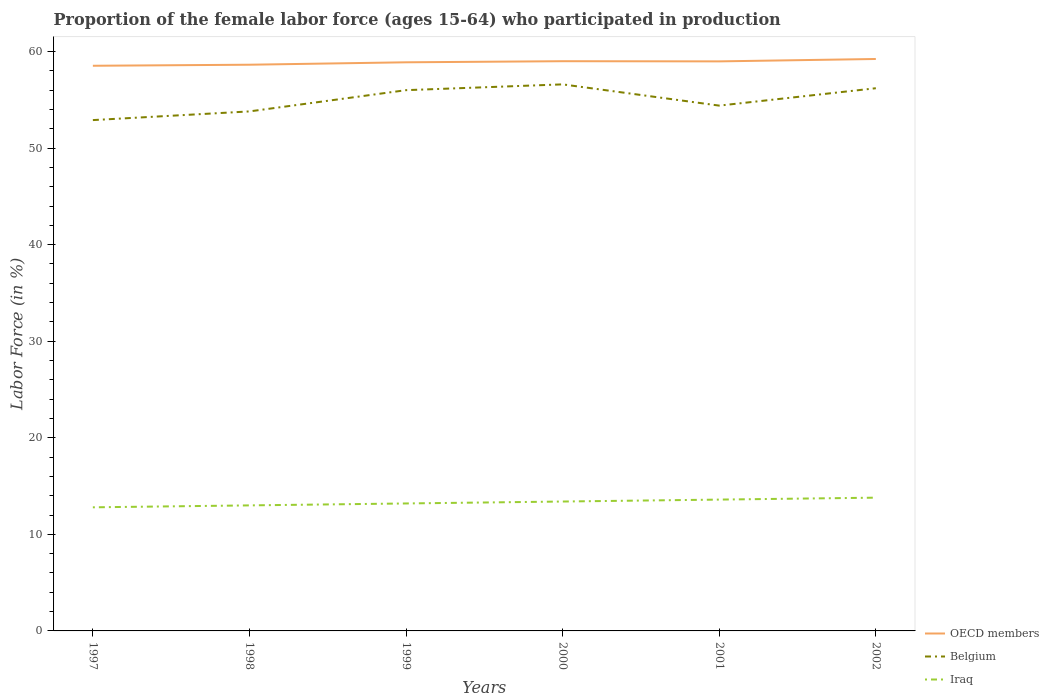Is the number of lines equal to the number of legend labels?
Ensure brevity in your answer.  Yes. Across all years, what is the maximum proportion of the female labor force who participated in production in OECD members?
Provide a succinct answer. 58.53. What is the total proportion of the female labor force who participated in production in Iraq in the graph?
Keep it short and to the point. -0.8. What is the difference between the highest and the second highest proportion of the female labor force who participated in production in OECD members?
Keep it short and to the point. 0.7. How many years are there in the graph?
Offer a very short reply. 6. How many legend labels are there?
Make the answer very short. 3. What is the title of the graph?
Make the answer very short. Proportion of the female labor force (ages 15-64) who participated in production. Does "Gambia, The" appear as one of the legend labels in the graph?
Offer a very short reply. No. What is the label or title of the X-axis?
Provide a succinct answer. Years. What is the Labor Force (in %) of OECD members in 1997?
Provide a succinct answer. 58.53. What is the Labor Force (in %) in Belgium in 1997?
Offer a very short reply. 52.9. What is the Labor Force (in %) in Iraq in 1997?
Provide a succinct answer. 12.8. What is the Labor Force (in %) in OECD members in 1998?
Provide a short and direct response. 58.64. What is the Labor Force (in %) of Belgium in 1998?
Ensure brevity in your answer.  53.8. What is the Labor Force (in %) of OECD members in 1999?
Your answer should be very brief. 58.89. What is the Labor Force (in %) in Iraq in 1999?
Give a very brief answer. 13.2. What is the Labor Force (in %) in OECD members in 2000?
Give a very brief answer. 59. What is the Labor Force (in %) of Belgium in 2000?
Your answer should be compact. 56.6. What is the Labor Force (in %) in Iraq in 2000?
Your answer should be very brief. 13.4. What is the Labor Force (in %) of OECD members in 2001?
Provide a succinct answer. 58.98. What is the Labor Force (in %) in Belgium in 2001?
Your answer should be very brief. 54.4. What is the Labor Force (in %) of Iraq in 2001?
Offer a terse response. 13.6. What is the Labor Force (in %) in OECD members in 2002?
Offer a terse response. 59.23. What is the Labor Force (in %) of Belgium in 2002?
Give a very brief answer. 56.2. What is the Labor Force (in %) in Iraq in 2002?
Keep it short and to the point. 13.8. Across all years, what is the maximum Labor Force (in %) of OECD members?
Provide a short and direct response. 59.23. Across all years, what is the maximum Labor Force (in %) in Belgium?
Your answer should be compact. 56.6. Across all years, what is the maximum Labor Force (in %) of Iraq?
Provide a succinct answer. 13.8. Across all years, what is the minimum Labor Force (in %) of OECD members?
Provide a succinct answer. 58.53. Across all years, what is the minimum Labor Force (in %) of Belgium?
Ensure brevity in your answer.  52.9. Across all years, what is the minimum Labor Force (in %) in Iraq?
Provide a succinct answer. 12.8. What is the total Labor Force (in %) in OECD members in the graph?
Ensure brevity in your answer.  353.26. What is the total Labor Force (in %) in Belgium in the graph?
Your answer should be very brief. 329.9. What is the total Labor Force (in %) of Iraq in the graph?
Make the answer very short. 79.8. What is the difference between the Labor Force (in %) in OECD members in 1997 and that in 1998?
Ensure brevity in your answer.  -0.11. What is the difference between the Labor Force (in %) of Belgium in 1997 and that in 1998?
Make the answer very short. -0.9. What is the difference between the Labor Force (in %) of Iraq in 1997 and that in 1998?
Your answer should be compact. -0.2. What is the difference between the Labor Force (in %) in OECD members in 1997 and that in 1999?
Your answer should be compact. -0.36. What is the difference between the Labor Force (in %) in OECD members in 1997 and that in 2000?
Provide a short and direct response. -0.47. What is the difference between the Labor Force (in %) in Belgium in 1997 and that in 2000?
Offer a very short reply. -3.7. What is the difference between the Labor Force (in %) of Iraq in 1997 and that in 2000?
Provide a short and direct response. -0.6. What is the difference between the Labor Force (in %) in OECD members in 1997 and that in 2001?
Offer a terse response. -0.46. What is the difference between the Labor Force (in %) in Belgium in 1997 and that in 2001?
Keep it short and to the point. -1.5. What is the difference between the Labor Force (in %) in OECD members in 1997 and that in 2002?
Give a very brief answer. -0.7. What is the difference between the Labor Force (in %) in Belgium in 1997 and that in 2002?
Your answer should be very brief. -3.3. What is the difference between the Labor Force (in %) of OECD members in 1998 and that in 1999?
Keep it short and to the point. -0.25. What is the difference between the Labor Force (in %) in Belgium in 1998 and that in 1999?
Provide a short and direct response. -2.2. What is the difference between the Labor Force (in %) of OECD members in 1998 and that in 2000?
Give a very brief answer. -0.36. What is the difference between the Labor Force (in %) of Belgium in 1998 and that in 2000?
Your response must be concise. -2.8. What is the difference between the Labor Force (in %) of Iraq in 1998 and that in 2000?
Your answer should be compact. -0.4. What is the difference between the Labor Force (in %) in OECD members in 1998 and that in 2001?
Give a very brief answer. -0.35. What is the difference between the Labor Force (in %) of Belgium in 1998 and that in 2001?
Your answer should be very brief. -0.6. What is the difference between the Labor Force (in %) of Iraq in 1998 and that in 2001?
Keep it short and to the point. -0.6. What is the difference between the Labor Force (in %) in OECD members in 1998 and that in 2002?
Provide a succinct answer. -0.59. What is the difference between the Labor Force (in %) of Belgium in 1998 and that in 2002?
Ensure brevity in your answer.  -2.4. What is the difference between the Labor Force (in %) in OECD members in 1999 and that in 2000?
Keep it short and to the point. -0.11. What is the difference between the Labor Force (in %) of Belgium in 1999 and that in 2000?
Give a very brief answer. -0.6. What is the difference between the Labor Force (in %) in OECD members in 1999 and that in 2001?
Keep it short and to the point. -0.1. What is the difference between the Labor Force (in %) in OECD members in 1999 and that in 2002?
Offer a terse response. -0.34. What is the difference between the Labor Force (in %) of Iraq in 1999 and that in 2002?
Offer a terse response. -0.6. What is the difference between the Labor Force (in %) in OECD members in 2000 and that in 2001?
Your answer should be compact. 0.02. What is the difference between the Labor Force (in %) in OECD members in 2000 and that in 2002?
Your response must be concise. -0.23. What is the difference between the Labor Force (in %) in OECD members in 2001 and that in 2002?
Keep it short and to the point. -0.25. What is the difference between the Labor Force (in %) in Iraq in 2001 and that in 2002?
Keep it short and to the point. -0.2. What is the difference between the Labor Force (in %) of OECD members in 1997 and the Labor Force (in %) of Belgium in 1998?
Provide a succinct answer. 4.73. What is the difference between the Labor Force (in %) in OECD members in 1997 and the Labor Force (in %) in Iraq in 1998?
Ensure brevity in your answer.  45.53. What is the difference between the Labor Force (in %) of Belgium in 1997 and the Labor Force (in %) of Iraq in 1998?
Offer a very short reply. 39.9. What is the difference between the Labor Force (in %) in OECD members in 1997 and the Labor Force (in %) in Belgium in 1999?
Your response must be concise. 2.53. What is the difference between the Labor Force (in %) of OECD members in 1997 and the Labor Force (in %) of Iraq in 1999?
Provide a short and direct response. 45.33. What is the difference between the Labor Force (in %) of Belgium in 1997 and the Labor Force (in %) of Iraq in 1999?
Offer a very short reply. 39.7. What is the difference between the Labor Force (in %) of OECD members in 1997 and the Labor Force (in %) of Belgium in 2000?
Give a very brief answer. 1.93. What is the difference between the Labor Force (in %) of OECD members in 1997 and the Labor Force (in %) of Iraq in 2000?
Keep it short and to the point. 45.13. What is the difference between the Labor Force (in %) of Belgium in 1997 and the Labor Force (in %) of Iraq in 2000?
Offer a terse response. 39.5. What is the difference between the Labor Force (in %) in OECD members in 1997 and the Labor Force (in %) in Belgium in 2001?
Your response must be concise. 4.13. What is the difference between the Labor Force (in %) of OECD members in 1997 and the Labor Force (in %) of Iraq in 2001?
Your answer should be compact. 44.93. What is the difference between the Labor Force (in %) of Belgium in 1997 and the Labor Force (in %) of Iraq in 2001?
Your answer should be very brief. 39.3. What is the difference between the Labor Force (in %) of OECD members in 1997 and the Labor Force (in %) of Belgium in 2002?
Your response must be concise. 2.33. What is the difference between the Labor Force (in %) of OECD members in 1997 and the Labor Force (in %) of Iraq in 2002?
Your answer should be very brief. 44.73. What is the difference between the Labor Force (in %) in Belgium in 1997 and the Labor Force (in %) in Iraq in 2002?
Offer a terse response. 39.1. What is the difference between the Labor Force (in %) in OECD members in 1998 and the Labor Force (in %) in Belgium in 1999?
Your response must be concise. 2.64. What is the difference between the Labor Force (in %) in OECD members in 1998 and the Labor Force (in %) in Iraq in 1999?
Make the answer very short. 45.44. What is the difference between the Labor Force (in %) of Belgium in 1998 and the Labor Force (in %) of Iraq in 1999?
Give a very brief answer. 40.6. What is the difference between the Labor Force (in %) in OECD members in 1998 and the Labor Force (in %) in Belgium in 2000?
Your response must be concise. 2.04. What is the difference between the Labor Force (in %) in OECD members in 1998 and the Labor Force (in %) in Iraq in 2000?
Provide a short and direct response. 45.24. What is the difference between the Labor Force (in %) of Belgium in 1998 and the Labor Force (in %) of Iraq in 2000?
Offer a terse response. 40.4. What is the difference between the Labor Force (in %) of OECD members in 1998 and the Labor Force (in %) of Belgium in 2001?
Offer a terse response. 4.24. What is the difference between the Labor Force (in %) of OECD members in 1998 and the Labor Force (in %) of Iraq in 2001?
Offer a terse response. 45.04. What is the difference between the Labor Force (in %) of Belgium in 1998 and the Labor Force (in %) of Iraq in 2001?
Your answer should be very brief. 40.2. What is the difference between the Labor Force (in %) of OECD members in 1998 and the Labor Force (in %) of Belgium in 2002?
Your response must be concise. 2.44. What is the difference between the Labor Force (in %) in OECD members in 1998 and the Labor Force (in %) in Iraq in 2002?
Make the answer very short. 44.84. What is the difference between the Labor Force (in %) in Belgium in 1998 and the Labor Force (in %) in Iraq in 2002?
Keep it short and to the point. 40. What is the difference between the Labor Force (in %) of OECD members in 1999 and the Labor Force (in %) of Belgium in 2000?
Provide a short and direct response. 2.29. What is the difference between the Labor Force (in %) of OECD members in 1999 and the Labor Force (in %) of Iraq in 2000?
Your response must be concise. 45.49. What is the difference between the Labor Force (in %) of Belgium in 1999 and the Labor Force (in %) of Iraq in 2000?
Give a very brief answer. 42.6. What is the difference between the Labor Force (in %) of OECD members in 1999 and the Labor Force (in %) of Belgium in 2001?
Offer a very short reply. 4.49. What is the difference between the Labor Force (in %) in OECD members in 1999 and the Labor Force (in %) in Iraq in 2001?
Offer a terse response. 45.29. What is the difference between the Labor Force (in %) of Belgium in 1999 and the Labor Force (in %) of Iraq in 2001?
Give a very brief answer. 42.4. What is the difference between the Labor Force (in %) of OECD members in 1999 and the Labor Force (in %) of Belgium in 2002?
Make the answer very short. 2.69. What is the difference between the Labor Force (in %) of OECD members in 1999 and the Labor Force (in %) of Iraq in 2002?
Offer a very short reply. 45.09. What is the difference between the Labor Force (in %) of Belgium in 1999 and the Labor Force (in %) of Iraq in 2002?
Your response must be concise. 42.2. What is the difference between the Labor Force (in %) of OECD members in 2000 and the Labor Force (in %) of Belgium in 2001?
Provide a short and direct response. 4.6. What is the difference between the Labor Force (in %) in OECD members in 2000 and the Labor Force (in %) in Iraq in 2001?
Your response must be concise. 45.4. What is the difference between the Labor Force (in %) in Belgium in 2000 and the Labor Force (in %) in Iraq in 2001?
Provide a succinct answer. 43. What is the difference between the Labor Force (in %) of OECD members in 2000 and the Labor Force (in %) of Belgium in 2002?
Your answer should be compact. 2.8. What is the difference between the Labor Force (in %) of OECD members in 2000 and the Labor Force (in %) of Iraq in 2002?
Ensure brevity in your answer.  45.2. What is the difference between the Labor Force (in %) in Belgium in 2000 and the Labor Force (in %) in Iraq in 2002?
Your answer should be very brief. 42.8. What is the difference between the Labor Force (in %) in OECD members in 2001 and the Labor Force (in %) in Belgium in 2002?
Your answer should be compact. 2.78. What is the difference between the Labor Force (in %) of OECD members in 2001 and the Labor Force (in %) of Iraq in 2002?
Offer a very short reply. 45.18. What is the difference between the Labor Force (in %) in Belgium in 2001 and the Labor Force (in %) in Iraq in 2002?
Ensure brevity in your answer.  40.6. What is the average Labor Force (in %) of OECD members per year?
Ensure brevity in your answer.  58.88. What is the average Labor Force (in %) in Belgium per year?
Make the answer very short. 54.98. In the year 1997, what is the difference between the Labor Force (in %) of OECD members and Labor Force (in %) of Belgium?
Your answer should be compact. 5.63. In the year 1997, what is the difference between the Labor Force (in %) of OECD members and Labor Force (in %) of Iraq?
Keep it short and to the point. 45.73. In the year 1997, what is the difference between the Labor Force (in %) in Belgium and Labor Force (in %) in Iraq?
Your response must be concise. 40.1. In the year 1998, what is the difference between the Labor Force (in %) in OECD members and Labor Force (in %) in Belgium?
Offer a very short reply. 4.84. In the year 1998, what is the difference between the Labor Force (in %) of OECD members and Labor Force (in %) of Iraq?
Your answer should be compact. 45.64. In the year 1998, what is the difference between the Labor Force (in %) in Belgium and Labor Force (in %) in Iraq?
Your answer should be compact. 40.8. In the year 1999, what is the difference between the Labor Force (in %) in OECD members and Labor Force (in %) in Belgium?
Your response must be concise. 2.89. In the year 1999, what is the difference between the Labor Force (in %) in OECD members and Labor Force (in %) in Iraq?
Provide a succinct answer. 45.69. In the year 1999, what is the difference between the Labor Force (in %) in Belgium and Labor Force (in %) in Iraq?
Keep it short and to the point. 42.8. In the year 2000, what is the difference between the Labor Force (in %) in OECD members and Labor Force (in %) in Belgium?
Provide a succinct answer. 2.4. In the year 2000, what is the difference between the Labor Force (in %) in OECD members and Labor Force (in %) in Iraq?
Your answer should be very brief. 45.6. In the year 2000, what is the difference between the Labor Force (in %) of Belgium and Labor Force (in %) of Iraq?
Keep it short and to the point. 43.2. In the year 2001, what is the difference between the Labor Force (in %) in OECD members and Labor Force (in %) in Belgium?
Provide a succinct answer. 4.58. In the year 2001, what is the difference between the Labor Force (in %) in OECD members and Labor Force (in %) in Iraq?
Your answer should be very brief. 45.38. In the year 2001, what is the difference between the Labor Force (in %) of Belgium and Labor Force (in %) of Iraq?
Ensure brevity in your answer.  40.8. In the year 2002, what is the difference between the Labor Force (in %) of OECD members and Labor Force (in %) of Belgium?
Make the answer very short. 3.03. In the year 2002, what is the difference between the Labor Force (in %) in OECD members and Labor Force (in %) in Iraq?
Provide a succinct answer. 45.43. In the year 2002, what is the difference between the Labor Force (in %) of Belgium and Labor Force (in %) of Iraq?
Your answer should be compact. 42.4. What is the ratio of the Labor Force (in %) in OECD members in 1997 to that in 1998?
Keep it short and to the point. 1. What is the ratio of the Labor Force (in %) of Belgium in 1997 to that in 1998?
Give a very brief answer. 0.98. What is the ratio of the Labor Force (in %) of Iraq in 1997 to that in 1998?
Offer a very short reply. 0.98. What is the ratio of the Labor Force (in %) in Belgium in 1997 to that in 1999?
Keep it short and to the point. 0.94. What is the ratio of the Labor Force (in %) of Iraq in 1997 to that in 1999?
Your answer should be compact. 0.97. What is the ratio of the Labor Force (in %) in Belgium in 1997 to that in 2000?
Keep it short and to the point. 0.93. What is the ratio of the Labor Force (in %) of Iraq in 1997 to that in 2000?
Your answer should be compact. 0.96. What is the ratio of the Labor Force (in %) in OECD members in 1997 to that in 2001?
Your answer should be very brief. 0.99. What is the ratio of the Labor Force (in %) in Belgium in 1997 to that in 2001?
Your response must be concise. 0.97. What is the ratio of the Labor Force (in %) in Iraq in 1997 to that in 2001?
Provide a succinct answer. 0.94. What is the ratio of the Labor Force (in %) of Belgium in 1997 to that in 2002?
Make the answer very short. 0.94. What is the ratio of the Labor Force (in %) in Iraq in 1997 to that in 2002?
Your answer should be very brief. 0.93. What is the ratio of the Labor Force (in %) in OECD members in 1998 to that in 1999?
Your answer should be compact. 1. What is the ratio of the Labor Force (in %) in Belgium in 1998 to that in 1999?
Your answer should be very brief. 0.96. What is the ratio of the Labor Force (in %) of Iraq in 1998 to that in 1999?
Your answer should be compact. 0.98. What is the ratio of the Labor Force (in %) in Belgium in 1998 to that in 2000?
Provide a short and direct response. 0.95. What is the ratio of the Labor Force (in %) of Iraq in 1998 to that in 2000?
Provide a short and direct response. 0.97. What is the ratio of the Labor Force (in %) of Iraq in 1998 to that in 2001?
Provide a succinct answer. 0.96. What is the ratio of the Labor Force (in %) of Belgium in 1998 to that in 2002?
Your response must be concise. 0.96. What is the ratio of the Labor Force (in %) in Iraq in 1998 to that in 2002?
Provide a succinct answer. 0.94. What is the ratio of the Labor Force (in %) in Iraq in 1999 to that in 2000?
Give a very brief answer. 0.99. What is the ratio of the Labor Force (in %) of Belgium in 1999 to that in 2001?
Ensure brevity in your answer.  1.03. What is the ratio of the Labor Force (in %) of Iraq in 1999 to that in 2001?
Ensure brevity in your answer.  0.97. What is the ratio of the Labor Force (in %) of Belgium in 1999 to that in 2002?
Provide a short and direct response. 1. What is the ratio of the Labor Force (in %) in Iraq in 1999 to that in 2002?
Ensure brevity in your answer.  0.96. What is the ratio of the Labor Force (in %) of Belgium in 2000 to that in 2001?
Your answer should be very brief. 1.04. What is the ratio of the Labor Force (in %) of Belgium in 2000 to that in 2002?
Keep it short and to the point. 1.01. What is the ratio of the Labor Force (in %) in Iraq in 2000 to that in 2002?
Provide a succinct answer. 0.97. What is the ratio of the Labor Force (in %) in OECD members in 2001 to that in 2002?
Your response must be concise. 1. What is the ratio of the Labor Force (in %) in Belgium in 2001 to that in 2002?
Your answer should be compact. 0.97. What is the ratio of the Labor Force (in %) of Iraq in 2001 to that in 2002?
Provide a succinct answer. 0.99. What is the difference between the highest and the second highest Labor Force (in %) in OECD members?
Provide a succinct answer. 0.23. What is the difference between the highest and the second highest Labor Force (in %) of Iraq?
Provide a short and direct response. 0.2. What is the difference between the highest and the lowest Labor Force (in %) in OECD members?
Ensure brevity in your answer.  0.7. 